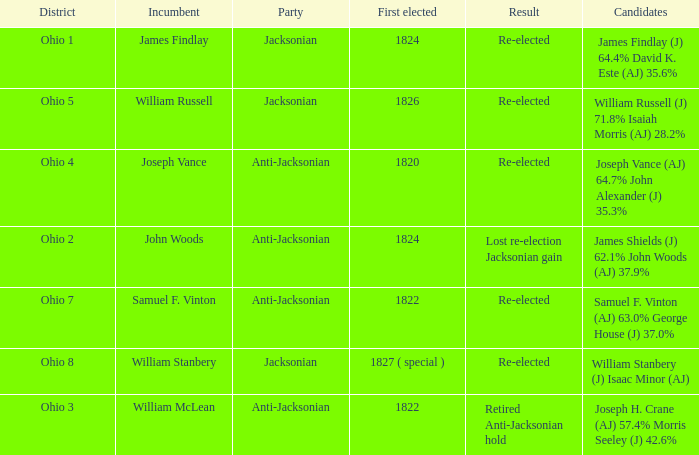What is the party of Joseph Vance? Anti-Jacksonian. 